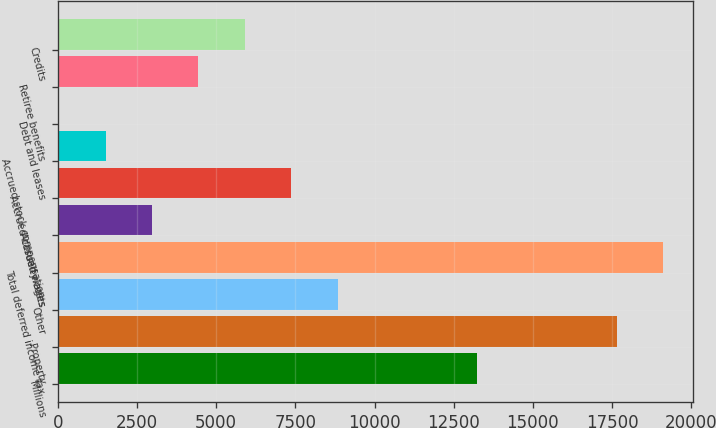Convert chart. <chart><loc_0><loc_0><loc_500><loc_500><bar_chart><fcel>Millions<fcel>Property<fcel>Other<fcel>Total deferred income tax<fcel>Accrued wages<fcel>Accrued casualty costs<fcel>Accrued stock compensation<fcel>Debt and leases<fcel>Retiree benefits<fcel>Credits<nl><fcel>13241.3<fcel>17641.4<fcel>8841.2<fcel>19108.1<fcel>2974.4<fcel>7374.5<fcel>1507.7<fcel>41<fcel>4441.1<fcel>5907.8<nl></chart> 